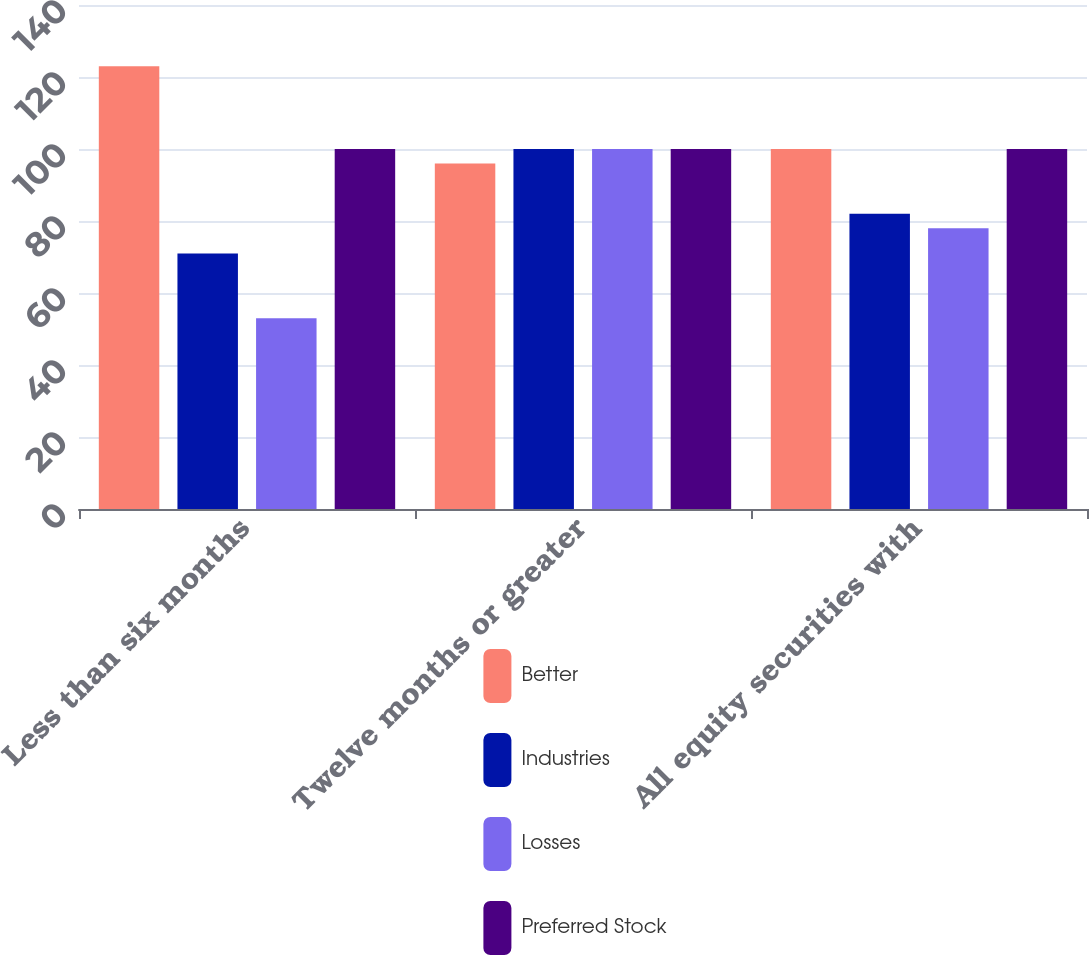Convert chart. <chart><loc_0><loc_0><loc_500><loc_500><stacked_bar_chart><ecel><fcel>Less than six months<fcel>Twelve months or greater<fcel>All equity securities with<nl><fcel>Better<fcel>123<fcel>96<fcel>100<nl><fcel>Industries<fcel>71<fcel>100<fcel>82<nl><fcel>Losses<fcel>53<fcel>100<fcel>78<nl><fcel>Preferred Stock<fcel>100<fcel>100<fcel>100<nl></chart> 